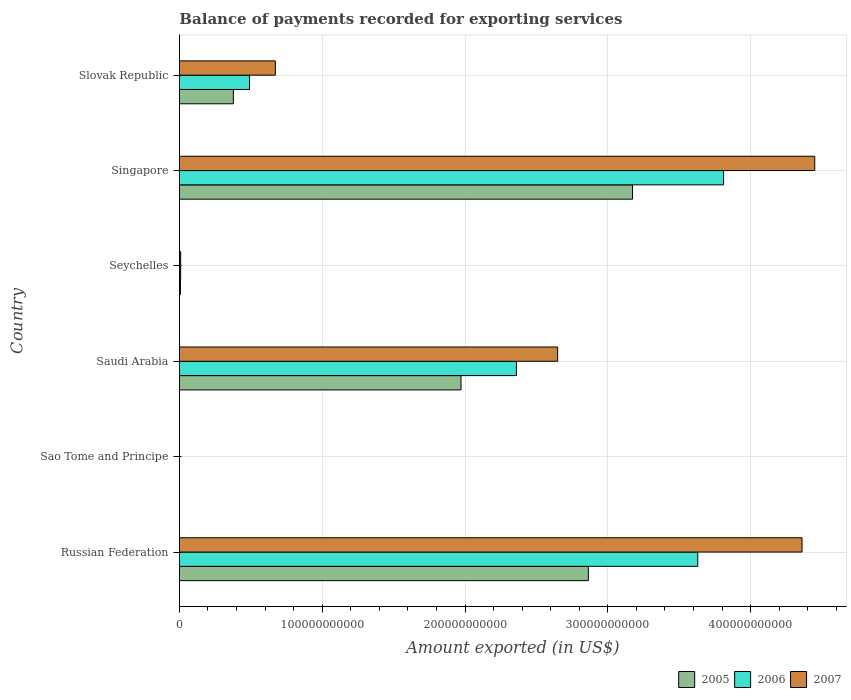How many groups of bars are there?
Your response must be concise. 6. Are the number of bars per tick equal to the number of legend labels?
Offer a very short reply. Yes. What is the label of the 3rd group of bars from the top?
Provide a short and direct response. Seychelles. In how many cases, is the number of bars for a given country not equal to the number of legend labels?
Your answer should be very brief. 0. What is the amount exported in 2005 in Sao Tome and Principe?
Offer a terse response. 1.79e+07. Across all countries, what is the maximum amount exported in 2007?
Provide a short and direct response. 4.45e+11. Across all countries, what is the minimum amount exported in 2005?
Give a very brief answer. 1.79e+07. In which country was the amount exported in 2005 maximum?
Make the answer very short. Singapore. In which country was the amount exported in 2005 minimum?
Offer a very short reply. Sao Tome and Principe. What is the total amount exported in 2005 in the graph?
Make the answer very short. 8.39e+11. What is the difference between the amount exported in 2007 in Seychelles and that in Slovak Republic?
Ensure brevity in your answer.  -6.63e+1. What is the difference between the amount exported in 2006 in Saudi Arabia and the amount exported in 2007 in Slovak Republic?
Provide a short and direct response. 1.69e+11. What is the average amount exported in 2007 per country?
Make the answer very short. 2.02e+11. What is the difference between the amount exported in 2007 and amount exported in 2006 in Saudi Arabia?
Give a very brief answer. 2.89e+1. In how many countries, is the amount exported in 2005 greater than 40000000000 US$?
Provide a short and direct response. 3. What is the ratio of the amount exported in 2006 in Russian Federation to that in Slovak Republic?
Keep it short and to the point. 7.4. Is the amount exported in 2007 in Sao Tome and Principe less than that in Seychelles?
Keep it short and to the point. Yes. What is the difference between the highest and the second highest amount exported in 2007?
Your answer should be compact. 8.89e+09. What is the difference between the highest and the lowest amount exported in 2007?
Offer a terse response. 4.45e+11. What does the 1st bar from the bottom in Slovak Republic represents?
Your answer should be very brief. 2005. Are all the bars in the graph horizontal?
Keep it short and to the point. Yes. How many countries are there in the graph?
Your answer should be very brief. 6. What is the difference between two consecutive major ticks on the X-axis?
Make the answer very short. 1.00e+11. Does the graph contain any zero values?
Your answer should be compact. No. Where does the legend appear in the graph?
Provide a short and direct response. Bottom right. How are the legend labels stacked?
Your answer should be very brief. Horizontal. What is the title of the graph?
Keep it short and to the point. Balance of payments recorded for exporting services. Does "1977" appear as one of the legend labels in the graph?
Your answer should be compact. No. What is the label or title of the X-axis?
Provide a succinct answer. Amount exported (in US$). What is the Amount exported (in US$) of 2005 in Russian Federation?
Give a very brief answer. 2.86e+11. What is the Amount exported (in US$) in 2006 in Russian Federation?
Ensure brevity in your answer.  3.63e+11. What is the Amount exported (in US$) in 2007 in Russian Federation?
Make the answer very short. 4.36e+11. What is the Amount exported (in US$) in 2005 in Sao Tome and Principe?
Make the answer very short. 1.79e+07. What is the Amount exported (in US$) in 2006 in Sao Tome and Principe?
Provide a succinct answer. 2.23e+07. What is the Amount exported (in US$) of 2007 in Sao Tome and Principe?
Your response must be concise. 2.03e+07. What is the Amount exported (in US$) of 2005 in Saudi Arabia?
Your response must be concise. 1.97e+11. What is the Amount exported (in US$) of 2006 in Saudi Arabia?
Your response must be concise. 2.36e+11. What is the Amount exported (in US$) in 2007 in Saudi Arabia?
Make the answer very short. 2.65e+11. What is the Amount exported (in US$) in 2005 in Seychelles?
Make the answer very short. 7.29e+08. What is the Amount exported (in US$) of 2006 in Seychelles?
Provide a short and direct response. 8.61e+08. What is the Amount exported (in US$) of 2007 in Seychelles?
Your answer should be very brief. 8.57e+08. What is the Amount exported (in US$) in 2005 in Singapore?
Your answer should be compact. 3.17e+11. What is the Amount exported (in US$) in 2006 in Singapore?
Offer a very short reply. 3.81e+11. What is the Amount exported (in US$) in 2007 in Singapore?
Make the answer very short. 4.45e+11. What is the Amount exported (in US$) in 2005 in Slovak Republic?
Keep it short and to the point. 3.78e+1. What is the Amount exported (in US$) in 2006 in Slovak Republic?
Your answer should be compact. 4.91e+1. What is the Amount exported (in US$) of 2007 in Slovak Republic?
Provide a short and direct response. 6.72e+1. Across all countries, what is the maximum Amount exported (in US$) of 2005?
Provide a succinct answer. 3.17e+11. Across all countries, what is the maximum Amount exported (in US$) of 2006?
Keep it short and to the point. 3.81e+11. Across all countries, what is the maximum Amount exported (in US$) in 2007?
Give a very brief answer. 4.45e+11. Across all countries, what is the minimum Amount exported (in US$) of 2005?
Provide a short and direct response. 1.79e+07. Across all countries, what is the minimum Amount exported (in US$) in 2006?
Your answer should be compact. 2.23e+07. Across all countries, what is the minimum Amount exported (in US$) of 2007?
Your response must be concise. 2.03e+07. What is the total Amount exported (in US$) of 2005 in the graph?
Your answer should be compact. 8.39e+11. What is the total Amount exported (in US$) in 2006 in the graph?
Offer a very short reply. 1.03e+12. What is the total Amount exported (in US$) in 2007 in the graph?
Your answer should be very brief. 1.21e+12. What is the difference between the Amount exported (in US$) in 2005 in Russian Federation and that in Sao Tome and Principe?
Your answer should be compact. 2.86e+11. What is the difference between the Amount exported (in US$) in 2006 in Russian Federation and that in Sao Tome and Principe?
Provide a short and direct response. 3.63e+11. What is the difference between the Amount exported (in US$) in 2007 in Russian Federation and that in Sao Tome and Principe?
Offer a very short reply. 4.36e+11. What is the difference between the Amount exported (in US$) of 2005 in Russian Federation and that in Saudi Arabia?
Provide a succinct answer. 8.92e+1. What is the difference between the Amount exported (in US$) in 2006 in Russian Federation and that in Saudi Arabia?
Offer a terse response. 1.27e+11. What is the difference between the Amount exported (in US$) of 2007 in Russian Federation and that in Saudi Arabia?
Offer a terse response. 1.71e+11. What is the difference between the Amount exported (in US$) of 2005 in Russian Federation and that in Seychelles?
Give a very brief answer. 2.86e+11. What is the difference between the Amount exported (in US$) in 2006 in Russian Federation and that in Seychelles?
Your answer should be compact. 3.62e+11. What is the difference between the Amount exported (in US$) of 2007 in Russian Federation and that in Seychelles?
Keep it short and to the point. 4.35e+11. What is the difference between the Amount exported (in US$) of 2005 in Russian Federation and that in Singapore?
Give a very brief answer. -3.09e+1. What is the difference between the Amount exported (in US$) of 2006 in Russian Federation and that in Singapore?
Give a very brief answer. -1.81e+1. What is the difference between the Amount exported (in US$) of 2007 in Russian Federation and that in Singapore?
Give a very brief answer. -8.89e+09. What is the difference between the Amount exported (in US$) of 2005 in Russian Federation and that in Slovak Republic?
Your answer should be very brief. 2.49e+11. What is the difference between the Amount exported (in US$) of 2006 in Russian Federation and that in Slovak Republic?
Your answer should be compact. 3.14e+11. What is the difference between the Amount exported (in US$) of 2007 in Russian Federation and that in Slovak Republic?
Make the answer very short. 3.69e+11. What is the difference between the Amount exported (in US$) in 2005 in Sao Tome and Principe and that in Saudi Arabia?
Provide a short and direct response. -1.97e+11. What is the difference between the Amount exported (in US$) in 2006 in Sao Tome and Principe and that in Saudi Arabia?
Provide a short and direct response. -2.36e+11. What is the difference between the Amount exported (in US$) in 2007 in Sao Tome and Principe and that in Saudi Arabia?
Your answer should be very brief. -2.65e+11. What is the difference between the Amount exported (in US$) of 2005 in Sao Tome and Principe and that in Seychelles?
Ensure brevity in your answer.  -7.12e+08. What is the difference between the Amount exported (in US$) in 2006 in Sao Tome and Principe and that in Seychelles?
Provide a short and direct response. -8.38e+08. What is the difference between the Amount exported (in US$) of 2007 in Sao Tome and Principe and that in Seychelles?
Make the answer very short. -8.37e+08. What is the difference between the Amount exported (in US$) in 2005 in Sao Tome and Principe and that in Singapore?
Provide a short and direct response. -3.17e+11. What is the difference between the Amount exported (in US$) in 2006 in Sao Tome and Principe and that in Singapore?
Give a very brief answer. -3.81e+11. What is the difference between the Amount exported (in US$) of 2007 in Sao Tome and Principe and that in Singapore?
Offer a terse response. -4.45e+11. What is the difference between the Amount exported (in US$) in 2005 in Sao Tome and Principe and that in Slovak Republic?
Offer a terse response. -3.78e+1. What is the difference between the Amount exported (in US$) in 2006 in Sao Tome and Principe and that in Slovak Republic?
Your answer should be compact. -4.91e+1. What is the difference between the Amount exported (in US$) in 2007 in Sao Tome and Principe and that in Slovak Republic?
Provide a short and direct response. -6.71e+1. What is the difference between the Amount exported (in US$) in 2005 in Saudi Arabia and that in Seychelles?
Offer a very short reply. 1.96e+11. What is the difference between the Amount exported (in US$) in 2006 in Saudi Arabia and that in Seychelles?
Provide a succinct answer. 2.35e+11. What is the difference between the Amount exported (in US$) in 2007 in Saudi Arabia and that in Seychelles?
Make the answer very short. 2.64e+11. What is the difference between the Amount exported (in US$) in 2005 in Saudi Arabia and that in Singapore?
Offer a terse response. -1.20e+11. What is the difference between the Amount exported (in US$) in 2006 in Saudi Arabia and that in Singapore?
Ensure brevity in your answer.  -1.45e+11. What is the difference between the Amount exported (in US$) in 2007 in Saudi Arabia and that in Singapore?
Keep it short and to the point. -1.80e+11. What is the difference between the Amount exported (in US$) of 2005 in Saudi Arabia and that in Slovak Republic?
Ensure brevity in your answer.  1.59e+11. What is the difference between the Amount exported (in US$) in 2006 in Saudi Arabia and that in Slovak Republic?
Give a very brief answer. 1.87e+11. What is the difference between the Amount exported (in US$) in 2007 in Saudi Arabia and that in Slovak Republic?
Your answer should be compact. 1.98e+11. What is the difference between the Amount exported (in US$) of 2005 in Seychelles and that in Singapore?
Your answer should be compact. -3.17e+11. What is the difference between the Amount exported (in US$) in 2006 in Seychelles and that in Singapore?
Make the answer very short. -3.80e+11. What is the difference between the Amount exported (in US$) in 2007 in Seychelles and that in Singapore?
Make the answer very short. -4.44e+11. What is the difference between the Amount exported (in US$) of 2005 in Seychelles and that in Slovak Republic?
Your answer should be very brief. -3.71e+1. What is the difference between the Amount exported (in US$) of 2006 in Seychelles and that in Slovak Republic?
Provide a succinct answer. -4.82e+1. What is the difference between the Amount exported (in US$) in 2007 in Seychelles and that in Slovak Republic?
Offer a very short reply. -6.63e+1. What is the difference between the Amount exported (in US$) of 2005 in Singapore and that in Slovak Republic?
Your answer should be compact. 2.79e+11. What is the difference between the Amount exported (in US$) in 2006 in Singapore and that in Slovak Republic?
Make the answer very short. 3.32e+11. What is the difference between the Amount exported (in US$) of 2007 in Singapore and that in Slovak Republic?
Ensure brevity in your answer.  3.78e+11. What is the difference between the Amount exported (in US$) in 2005 in Russian Federation and the Amount exported (in US$) in 2006 in Sao Tome and Principe?
Ensure brevity in your answer.  2.86e+11. What is the difference between the Amount exported (in US$) of 2005 in Russian Federation and the Amount exported (in US$) of 2007 in Sao Tome and Principe?
Keep it short and to the point. 2.86e+11. What is the difference between the Amount exported (in US$) in 2006 in Russian Federation and the Amount exported (in US$) in 2007 in Sao Tome and Principe?
Your response must be concise. 3.63e+11. What is the difference between the Amount exported (in US$) in 2005 in Russian Federation and the Amount exported (in US$) in 2006 in Saudi Arabia?
Keep it short and to the point. 5.04e+1. What is the difference between the Amount exported (in US$) of 2005 in Russian Federation and the Amount exported (in US$) of 2007 in Saudi Arabia?
Your answer should be very brief. 2.15e+1. What is the difference between the Amount exported (in US$) of 2006 in Russian Federation and the Amount exported (in US$) of 2007 in Saudi Arabia?
Provide a succinct answer. 9.81e+1. What is the difference between the Amount exported (in US$) of 2005 in Russian Federation and the Amount exported (in US$) of 2006 in Seychelles?
Your answer should be very brief. 2.85e+11. What is the difference between the Amount exported (in US$) of 2005 in Russian Federation and the Amount exported (in US$) of 2007 in Seychelles?
Your response must be concise. 2.85e+11. What is the difference between the Amount exported (in US$) of 2006 in Russian Federation and the Amount exported (in US$) of 2007 in Seychelles?
Keep it short and to the point. 3.62e+11. What is the difference between the Amount exported (in US$) in 2005 in Russian Federation and the Amount exported (in US$) in 2006 in Singapore?
Ensure brevity in your answer.  -9.47e+1. What is the difference between the Amount exported (in US$) in 2005 in Russian Federation and the Amount exported (in US$) in 2007 in Singapore?
Keep it short and to the point. -1.59e+11. What is the difference between the Amount exported (in US$) of 2006 in Russian Federation and the Amount exported (in US$) of 2007 in Singapore?
Your answer should be very brief. -8.19e+1. What is the difference between the Amount exported (in US$) in 2005 in Russian Federation and the Amount exported (in US$) in 2006 in Slovak Republic?
Make the answer very short. 2.37e+11. What is the difference between the Amount exported (in US$) in 2005 in Russian Federation and the Amount exported (in US$) in 2007 in Slovak Republic?
Offer a very short reply. 2.19e+11. What is the difference between the Amount exported (in US$) in 2006 in Russian Federation and the Amount exported (in US$) in 2007 in Slovak Republic?
Your response must be concise. 2.96e+11. What is the difference between the Amount exported (in US$) of 2005 in Sao Tome and Principe and the Amount exported (in US$) of 2006 in Saudi Arabia?
Your response must be concise. -2.36e+11. What is the difference between the Amount exported (in US$) in 2005 in Sao Tome and Principe and the Amount exported (in US$) in 2007 in Saudi Arabia?
Provide a short and direct response. -2.65e+11. What is the difference between the Amount exported (in US$) of 2006 in Sao Tome and Principe and the Amount exported (in US$) of 2007 in Saudi Arabia?
Provide a succinct answer. -2.65e+11. What is the difference between the Amount exported (in US$) in 2005 in Sao Tome and Principe and the Amount exported (in US$) in 2006 in Seychelles?
Provide a short and direct response. -8.43e+08. What is the difference between the Amount exported (in US$) of 2005 in Sao Tome and Principe and the Amount exported (in US$) of 2007 in Seychelles?
Your answer should be very brief. -8.39e+08. What is the difference between the Amount exported (in US$) in 2006 in Sao Tome and Principe and the Amount exported (in US$) in 2007 in Seychelles?
Offer a terse response. -8.35e+08. What is the difference between the Amount exported (in US$) of 2005 in Sao Tome and Principe and the Amount exported (in US$) of 2006 in Singapore?
Make the answer very short. -3.81e+11. What is the difference between the Amount exported (in US$) of 2005 in Sao Tome and Principe and the Amount exported (in US$) of 2007 in Singapore?
Offer a very short reply. -4.45e+11. What is the difference between the Amount exported (in US$) in 2006 in Sao Tome and Principe and the Amount exported (in US$) in 2007 in Singapore?
Keep it short and to the point. -4.45e+11. What is the difference between the Amount exported (in US$) in 2005 in Sao Tome and Principe and the Amount exported (in US$) in 2006 in Slovak Republic?
Your answer should be compact. -4.91e+1. What is the difference between the Amount exported (in US$) in 2005 in Sao Tome and Principe and the Amount exported (in US$) in 2007 in Slovak Republic?
Your response must be concise. -6.72e+1. What is the difference between the Amount exported (in US$) in 2006 in Sao Tome and Principe and the Amount exported (in US$) in 2007 in Slovak Republic?
Provide a short and direct response. -6.71e+1. What is the difference between the Amount exported (in US$) in 2005 in Saudi Arabia and the Amount exported (in US$) in 2006 in Seychelles?
Give a very brief answer. 1.96e+11. What is the difference between the Amount exported (in US$) of 2005 in Saudi Arabia and the Amount exported (in US$) of 2007 in Seychelles?
Provide a succinct answer. 1.96e+11. What is the difference between the Amount exported (in US$) of 2006 in Saudi Arabia and the Amount exported (in US$) of 2007 in Seychelles?
Offer a terse response. 2.35e+11. What is the difference between the Amount exported (in US$) in 2005 in Saudi Arabia and the Amount exported (in US$) in 2006 in Singapore?
Keep it short and to the point. -1.84e+11. What is the difference between the Amount exported (in US$) of 2005 in Saudi Arabia and the Amount exported (in US$) of 2007 in Singapore?
Ensure brevity in your answer.  -2.48e+11. What is the difference between the Amount exported (in US$) of 2006 in Saudi Arabia and the Amount exported (in US$) of 2007 in Singapore?
Give a very brief answer. -2.09e+11. What is the difference between the Amount exported (in US$) in 2005 in Saudi Arabia and the Amount exported (in US$) in 2006 in Slovak Republic?
Offer a terse response. 1.48e+11. What is the difference between the Amount exported (in US$) of 2005 in Saudi Arabia and the Amount exported (in US$) of 2007 in Slovak Republic?
Offer a very short reply. 1.30e+11. What is the difference between the Amount exported (in US$) of 2006 in Saudi Arabia and the Amount exported (in US$) of 2007 in Slovak Republic?
Keep it short and to the point. 1.69e+11. What is the difference between the Amount exported (in US$) in 2005 in Seychelles and the Amount exported (in US$) in 2006 in Singapore?
Keep it short and to the point. -3.80e+11. What is the difference between the Amount exported (in US$) of 2005 in Seychelles and the Amount exported (in US$) of 2007 in Singapore?
Your response must be concise. -4.44e+11. What is the difference between the Amount exported (in US$) in 2006 in Seychelles and the Amount exported (in US$) in 2007 in Singapore?
Offer a terse response. -4.44e+11. What is the difference between the Amount exported (in US$) of 2005 in Seychelles and the Amount exported (in US$) of 2006 in Slovak Republic?
Keep it short and to the point. -4.83e+1. What is the difference between the Amount exported (in US$) of 2005 in Seychelles and the Amount exported (in US$) of 2007 in Slovak Republic?
Provide a succinct answer. -6.64e+1. What is the difference between the Amount exported (in US$) of 2006 in Seychelles and the Amount exported (in US$) of 2007 in Slovak Republic?
Ensure brevity in your answer.  -6.63e+1. What is the difference between the Amount exported (in US$) of 2005 in Singapore and the Amount exported (in US$) of 2006 in Slovak Republic?
Provide a succinct answer. 2.68e+11. What is the difference between the Amount exported (in US$) of 2005 in Singapore and the Amount exported (in US$) of 2007 in Slovak Republic?
Provide a short and direct response. 2.50e+11. What is the difference between the Amount exported (in US$) of 2006 in Singapore and the Amount exported (in US$) of 2007 in Slovak Republic?
Provide a short and direct response. 3.14e+11. What is the average Amount exported (in US$) of 2005 per country?
Make the answer very short. 1.40e+11. What is the average Amount exported (in US$) in 2006 per country?
Offer a terse response. 1.72e+11. What is the average Amount exported (in US$) in 2007 per country?
Your response must be concise. 2.02e+11. What is the difference between the Amount exported (in US$) of 2005 and Amount exported (in US$) of 2006 in Russian Federation?
Provide a short and direct response. -7.66e+1. What is the difference between the Amount exported (in US$) in 2005 and Amount exported (in US$) in 2007 in Russian Federation?
Offer a terse response. -1.50e+11. What is the difference between the Amount exported (in US$) of 2006 and Amount exported (in US$) of 2007 in Russian Federation?
Ensure brevity in your answer.  -7.30e+1. What is the difference between the Amount exported (in US$) in 2005 and Amount exported (in US$) in 2006 in Sao Tome and Principe?
Offer a very short reply. -4.35e+06. What is the difference between the Amount exported (in US$) of 2005 and Amount exported (in US$) of 2007 in Sao Tome and Principe?
Your answer should be compact. -2.36e+06. What is the difference between the Amount exported (in US$) of 2006 and Amount exported (in US$) of 2007 in Sao Tome and Principe?
Offer a terse response. 1.99e+06. What is the difference between the Amount exported (in US$) of 2005 and Amount exported (in US$) of 2006 in Saudi Arabia?
Keep it short and to the point. -3.88e+1. What is the difference between the Amount exported (in US$) of 2005 and Amount exported (in US$) of 2007 in Saudi Arabia?
Give a very brief answer. -6.77e+1. What is the difference between the Amount exported (in US$) of 2006 and Amount exported (in US$) of 2007 in Saudi Arabia?
Keep it short and to the point. -2.89e+1. What is the difference between the Amount exported (in US$) of 2005 and Amount exported (in US$) of 2006 in Seychelles?
Offer a very short reply. -1.31e+08. What is the difference between the Amount exported (in US$) in 2005 and Amount exported (in US$) in 2007 in Seychelles?
Your answer should be compact. -1.28e+08. What is the difference between the Amount exported (in US$) in 2006 and Amount exported (in US$) in 2007 in Seychelles?
Provide a succinct answer. 3.32e+06. What is the difference between the Amount exported (in US$) in 2005 and Amount exported (in US$) in 2006 in Singapore?
Keep it short and to the point. -6.38e+1. What is the difference between the Amount exported (in US$) of 2005 and Amount exported (in US$) of 2007 in Singapore?
Keep it short and to the point. -1.28e+11. What is the difference between the Amount exported (in US$) of 2006 and Amount exported (in US$) of 2007 in Singapore?
Provide a short and direct response. -6.38e+1. What is the difference between the Amount exported (in US$) of 2005 and Amount exported (in US$) of 2006 in Slovak Republic?
Your response must be concise. -1.13e+1. What is the difference between the Amount exported (in US$) in 2005 and Amount exported (in US$) in 2007 in Slovak Republic?
Provide a succinct answer. -2.94e+1. What is the difference between the Amount exported (in US$) in 2006 and Amount exported (in US$) in 2007 in Slovak Republic?
Provide a short and direct response. -1.81e+1. What is the ratio of the Amount exported (in US$) of 2005 in Russian Federation to that in Sao Tome and Principe?
Your answer should be very brief. 1.60e+04. What is the ratio of the Amount exported (in US$) in 2006 in Russian Federation to that in Sao Tome and Principe?
Offer a terse response. 1.63e+04. What is the ratio of the Amount exported (in US$) of 2007 in Russian Federation to that in Sao Tome and Principe?
Make the answer very short. 2.15e+04. What is the ratio of the Amount exported (in US$) of 2005 in Russian Federation to that in Saudi Arabia?
Make the answer very short. 1.45. What is the ratio of the Amount exported (in US$) in 2006 in Russian Federation to that in Saudi Arabia?
Provide a short and direct response. 1.54. What is the ratio of the Amount exported (in US$) in 2007 in Russian Federation to that in Saudi Arabia?
Keep it short and to the point. 1.65. What is the ratio of the Amount exported (in US$) in 2005 in Russian Federation to that in Seychelles?
Your response must be concise. 392.54. What is the ratio of the Amount exported (in US$) in 2006 in Russian Federation to that in Seychelles?
Keep it short and to the point. 421.75. What is the ratio of the Amount exported (in US$) of 2007 in Russian Federation to that in Seychelles?
Your answer should be compact. 508.54. What is the ratio of the Amount exported (in US$) in 2005 in Russian Federation to that in Singapore?
Make the answer very short. 0.9. What is the ratio of the Amount exported (in US$) of 2006 in Russian Federation to that in Singapore?
Your answer should be very brief. 0.95. What is the ratio of the Amount exported (in US$) of 2005 in Russian Federation to that in Slovak Republic?
Your response must be concise. 7.58. What is the ratio of the Amount exported (in US$) of 2006 in Russian Federation to that in Slovak Republic?
Keep it short and to the point. 7.4. What is the ratio of the Amount exported (in US$) in 2007 in Russian Federation to that in Slovak Republic?
Offer a terse response. 6.49. What is the ratio of the Amount exported (in US$) of 2005 in Sao Tome and Principe to that in Saudi Arabia?
Your answer should be compact. 0. What is the ratio of the Amount exported (in US$) of 2005 in Sao Tome and Principe to that in Seychelles?
Your response must be concise. 0.02. What is the ratio of the Amount exported (in US$) of 2006 in Sao Tome and Principe to that in Seychelles?
Provide a succinct answer. 0.03. What is the ratio of the Amount exported (in US$) in 2007 in Sao Tome and Principe to that in Seychelles?
Your answer should be very brief. 0.02. What is the ratio of the Amount exported (in US$) of 2005 in Sao Tome and Principe to that in Slovak Republic?
Your answer should be compact. 0. What is the ratio of the Amount exported (in US$) of 2005 in Saudi Arabia to that in Seychelles?
Provide a short and direct response. 270.3. What is the ratio of the Amount exported (in US$) in 2006 in Saudi Arabia to that in Seychelles?
Make the answer very short. 274.2. What is the ratio of the Amount exported (in US$) of 2007 in Saudi Arabia to that in Seychelles?
Give a very brief answer. 308.93. What is the ratio of the Amount exported (in US$) in 2005 in Saudi Arabia to that in Singapore?
Make the answer very short. 0.62. What is the ratio of the Amount exported (in US$) in 2006 in Saudi Arabia to that in Singapore?
Offer a terse response. 0.62. What is the ratio of the Amount exported (in US$) of 2007 in Saudi Arabia to that in Singapore?
Ensure brevity in your answer.  0.6. What is the ratio of the Amount exported (in US$) in 2005 in Saudi Arabia to that in Slovak Republic?
Your answer should be compact. 5.22. What is the ratio of the Amount exported (in US$) of 2006 in Saudi Arabia to that in Slovak Republic?
Your answer should be compact. 4.81. What is the ratio of the Amount exported (in US$) of 2007 in Saudi Arabia to that in Slovak Republic?
Keep it short and to the point. 3.94. What is the ratio of the Amount exported (in US$) in 2005 in Seychelles to that in Singapore?
Provide a succinct answer. 0. What is the ratio of the Amount exported (in US$) of 2006 in Seychelles to that in Singapore?
Provide a short and direct response. 0. What is the ratio of the Amount exported (in US$) of 2007 in Seychelles to that in Singapore?
Your answer should be very brief. 0. What is the ratio of the Amount exported (in US$) of 2005 in Seychelles to that in Slovak Republic?
Provide a succinct answer. 0.02. What is the ratio of the Amount exported (in US$) in 2006 in Seychelles to that in Slovak Republic?
Make the answer very short. 0.02. What is the ratio of the Amount exported (in US$) of 2007 in Seychelles to that in Slovak Republic?
Offer a terse response. 0.01. What is the ratio of the Amount exported (in US$) of 2005 in Singapore to that in Slovak Republic?
Keep it short and to the point. 8.39. What is the ratio of the Amount exported (in US$) in 2006 in Singapore to that in Slovak Republic?
Give a very brief answer. 7.76. What is the ratio of the Amount exported (in US$) in 2007 in Singapore to that in Slovak Republic?
Provide a short and direct response. 6.62. What is the difference between the highest and the second highest Amount exported (in US$) in 2005?
Your response must be concise. 3.09e+1. What is the difference between the highest and the second highest Amount exported (in US$) of 2006?
Offer a terse response. 1.81e+1. What is the difference between the highest and the second highest Amount exported (in US$) of 2007?
Offer a terse response. 8.89e+09. What is the difference between the highest and the lowest Amount exported (in US$) of 2005?
Your answer should be compact. 3.17e+11. What is the difference between the highest and the lowest Amount exported (in US$) in 2006?
Keep it short and to the point. 3.81e+11. What is the difference between the highest and the lowest Amount exported (in US$) of 2007?
Your response must be concise. 4.45e+11. 